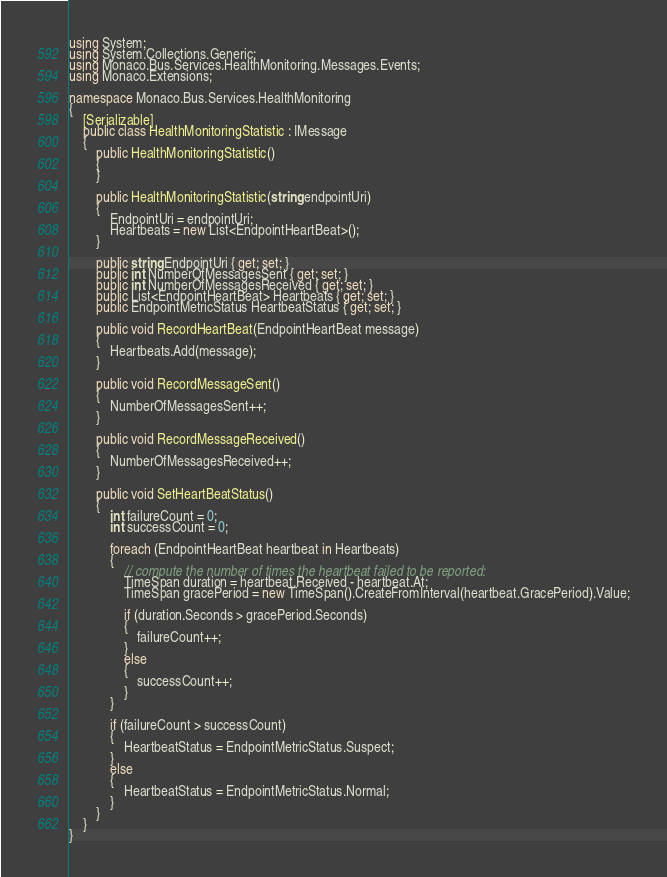<code> <loc_0><loc_0><loc_500><loc_500><_C#_>using System;
using System.Collections.Generic;
using Monaco.Bus.Services.HealthMonitoring.Messages.Events;
using Monaco.Extensions;

namespace Monaco.Bus.Services.HealthMonitoring
{
	[Serializable]
	public class HealthMonitoringStatistic : IMessage
	{
		public HealthMonitoringStatistic()
		{
		}

		public HealthMonitoringStatistic(string endpointUri)
		{
			EndpointUri = endpointUri;
			Heartbeats = new List<EndpointHeartBeat>();
		}

		public string EndpointUri { get; set; }
		public int NumberOfMessagesSent { get; set; }
		public int NumberOfMessagesReceived { get; set; }
		public List<EndpointHeartBeat> Heartbeats { get; set; }
		public EndpointMetricStatus HeartbeatStatus { get; set; }

		public void RecordHeartBeat(EndpointHeartBeat message)
		{
			Heartbeats.Add(message);
		}

		public void RecordMessageSent()
		{
			NumberOfMessagesSent++;
		}

		public void RecordMessageReceived()
		{
			NumberOfMessagesReceived++;
		}

		public void SetHeartBeatStatus()
		{
			int failureCount = 0;
			int successCount = 0;

			foreach (EndpointHeartBeat heartbeat in Heartbeats)
			{
				// compute the number of times the heartbeat failed to be reported:
				TimeSpan duration = heartbeat.Received - heartbeat.At;
				TimeSpan gracePeriod = new TimeSpan().CreateFromInterval(heartbeat.GracePeriod).Value;

				if (duration.Seconds > gracePeriod.Seconds)
				{
					failureCount++;
				}
				else
				{
					successCount++;
				}
			}

			if (failureCount > successCount)
			{
				HeartbeatStatus = EndpointMetricStatus.Suspect;
			}
			else
			{
				HeartbeatStatus = EndpointMetricStatus.Normal;
			}
		}
	}
}</code> 